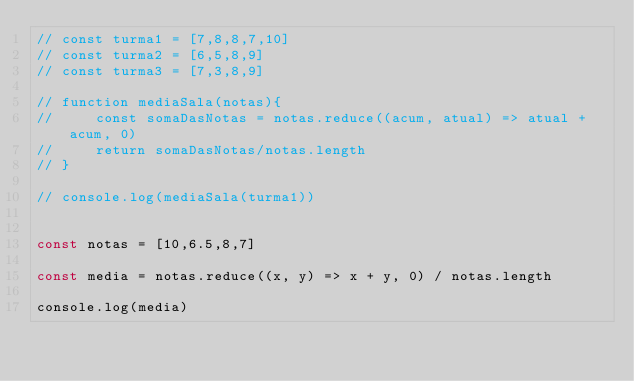Convert code to text. <code><loc_0><loc_0><loc_500><loc_500><_JavaScript_>// const turma1 = [7,8,8,7,10]
// const turma2 = [6,5,8,9]
// const turma3 = [7,3,8,9]

// function mediaSala(notas){
//     const somaDasNotas = notas.reduce((acum, atual) => atual + acum, 0)
//     return somaDasNotas/notas.length
// }

// console.log(mediaSala(turma1))


const notas = [10,6.5,8,7]

const media = notas.reduce((x, y) => x + y, 0) / notas.length

console.log(media)</code> 